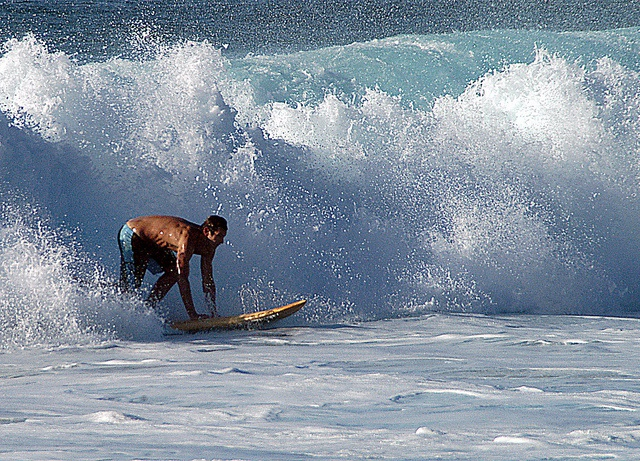Describe the objects in this image and their specific colors. I can see people in blue, black, gray, brown, and maroon tones and surfboard in blue, black, maroon, gray, and navy tones in this image. 